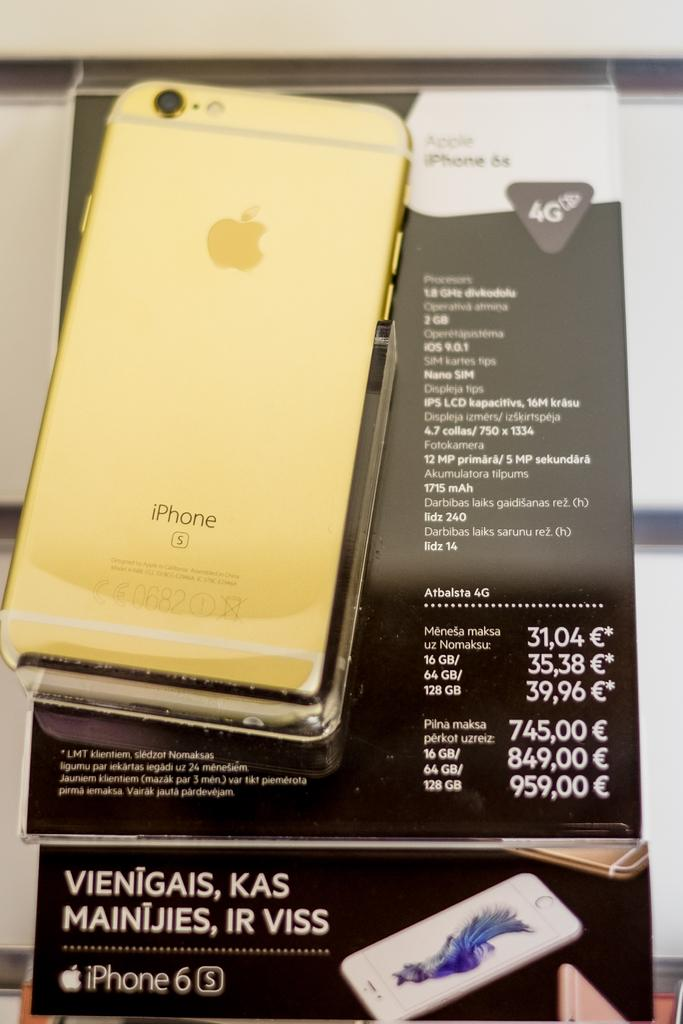<image>
Give a short and clear explanation of the subsequent image. gold iphone 6s on black display showing prices based on 16,64,128gb memory configurations 